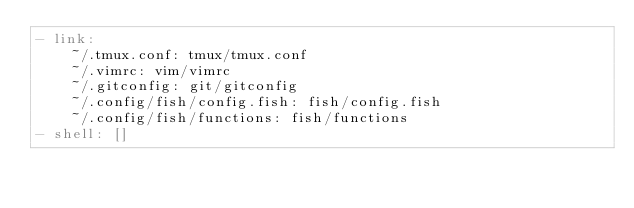<code> <loc_0><loc_0><loc_500><loc_500><_YAML_>- link:
    ~/.tmux.conf: tmux/tmux.conf
    ~/.vimrc: vim/vimrc
    ~/.gitconfig: git/gitconfig
    ~/.config/fish/config.fish: fish/config.fish
    ~/.config/fish/functions: fish/functions
- shell: []
</code> 